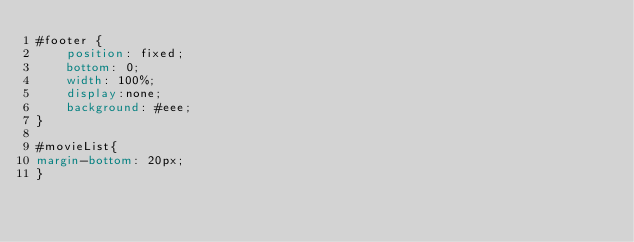<code> <loc_0><loc_0><loc_500><loc_500><_CSS_>#footer {
    position: fixed;
    bottom: 0;
    width: 100%;
    display:none;
    background: #eee;
}

#movieList{
margin-bottom: 20px;
}
</code> 